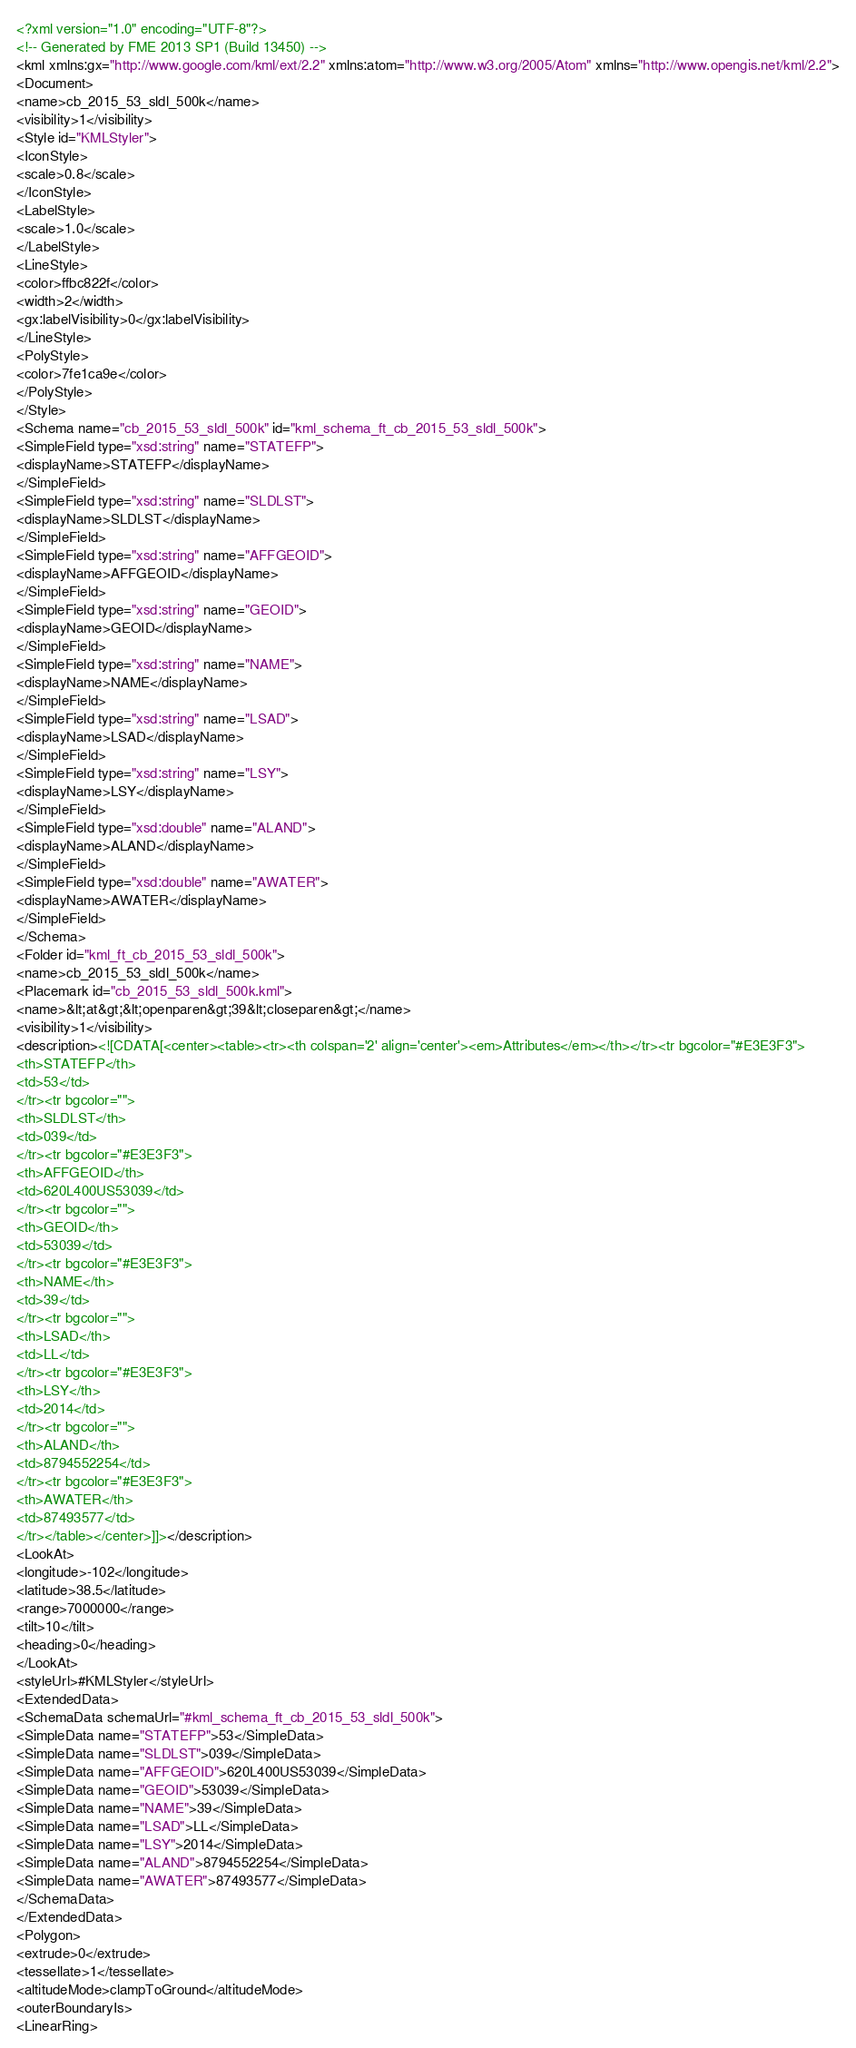<code> <loc_0><loc_0><loc_500><loc_500><_XML_><?xml version="1.0" encoding="UTF-8"?>
<!-- Generated by FME 2013 SP1 (Build 13450) -->
<kml xmlns:gx="http://www.google.com/kml/ext/2.2" xmlns:atom="http://www.w3.org/2005/Atom" xmlns="http://www.opengis.net/kml/2.2">
<Document>
<name>cb_2015_53_sldl_500k</name>
<visibility>1</visibility>
<Style id="KMLStyler">
<IconStyle>
<scale>0.8</scale>
</IconStyle>
<LabelStyle>
<scale>1.0</scale>
</LabelStyle>
<LineStyle>
<color>ffbc822f</color>
<width>2</width>
<gx:labelVisibility>0</gx:labelVisibility>
</LineStyle>
<PolyStyle>
<color>7fe1ca9e</color>
</PolyStyle>
</Style>
<Schema name="cb_2015_53_sldl_500k" id="kml_schema_ft_cb_2015_53_sldl_500k">
<SimpleField type="xsd:string" name="STATEFP">
<displayName>STATEFP</displayName>
</SimpleField>
<SimpleField type="xsd:string" name="SLDLST">
<displayName>SLDLST</displayName>
</SimpleField>
<SimpleField type="xsd:string" name="AFFGEOID">
<displayName>AFFGEOID</displayName>
</SimpleField>
<SimpleField type="xsd:string" name="GEOID">
<displayName>GEOID</displayName>
</SimpleField>
<SimpleField type="xsd:string" name="NAME">
<displayName>NAME</displayName>
</SimpleField>
<SimpleField type="xsd:string" name="LSAD">
<displayName>LSAD</displayName>
</SimpleField>
<SimpleField type="xsd:string" name="LSY">
<displayName>LSY</displayName>
</SimpleField>
<SimpleField type="xsd:double" name="ALAND">
<displayName>ALAND</displayName>
</SimpleField>
<SimpleField type="xsd:double" name="AWATER">
<displayName>AWATER</displayName>
</SimpleField>
</Schema>
<Folder id="kml_ft_cb_2015_53_sldl_500k">
<name>cb_2015_53_sldl_500k</name>
<Placemark id="cb_2015_53_sldl_500k.kml">
<name>&lt;at&gt;&lt;openparen&gt;39&lt;closeparen&gt;</name>
<visibility>1</visibility>
<description><![CDATA[<center><table><tr><th colspan='2' align='center'><em>Attributes</em></th></tr><tr bgcolor="#E3E3F3">
<th>STATEFP</th>
<td>53</td>
</tr><tr bgcolor="">
<th>SLDLST</th>
<td>039</td>
</tr><tr bgcolor="#E3E3F3">
<th>AFFGEOID</th>
<td>620L400US53039</td>
</tr><tr bgcolor="">
<th>GEOID</th>
<td>53039</td>
</tr><tr bgcolor="#E3E3F3">
<th>NAME</th>
<td>39</td>
</tr><tr bgcolor="">
<th>LSAD</th>
<td>LL</td>
</tr><tr bgcolor="#E3E3F3">
<th>LSY</th>
<td>2014</td>
</tr><tr bgcolor="">
<th>ALAND</th>
<td>8794552254</td>
</tr><tr bgcolor="#E3E3F3">
<th>AWATER</th>
<td>87493577</td>
</tr></table></center>]]></description>
<LookAt>
<longitude>-102</longitude>
<latitude>38.5</latitude>
<range>7000000</range>
<tilt>10</tilt>
<heading>0</heading>
</LookAt>
<styleUrl>#KMLStyler</styleUrl>
<ExtendedData>
<SchemaData schemaUrl="#kml_schema_ft_cb_2015_53_sldl_500k">
<SimpleData name="STATEFP">53</SimpleData>
<SimpleData name="SLDLST">039</SimpleData>
<SimpleData name="AFFGEOID">620L400US53039</SimpleData>
<SimpleData name="GEOID">53039</SimpleData>
<SimpleData name="NAME">39</SimpleData>
<SimpleData name="LSAD">LL</SimpleData>
<SimpleData name="LSY">2014</SimpleData>
<SimpleData name="ALAND">8794552254</SimpleData>
<SimpleData name="AWATER">87493577</SimpleData>
</SchemaData>
</ExtendedData>
<Polygon>
<extrude>0</extrude>
<tessellate>1</tessellate>
<altitudeMode>clampToGround</altitudeMode>
<outerBoundaryIs>
<LinearRing></code> 